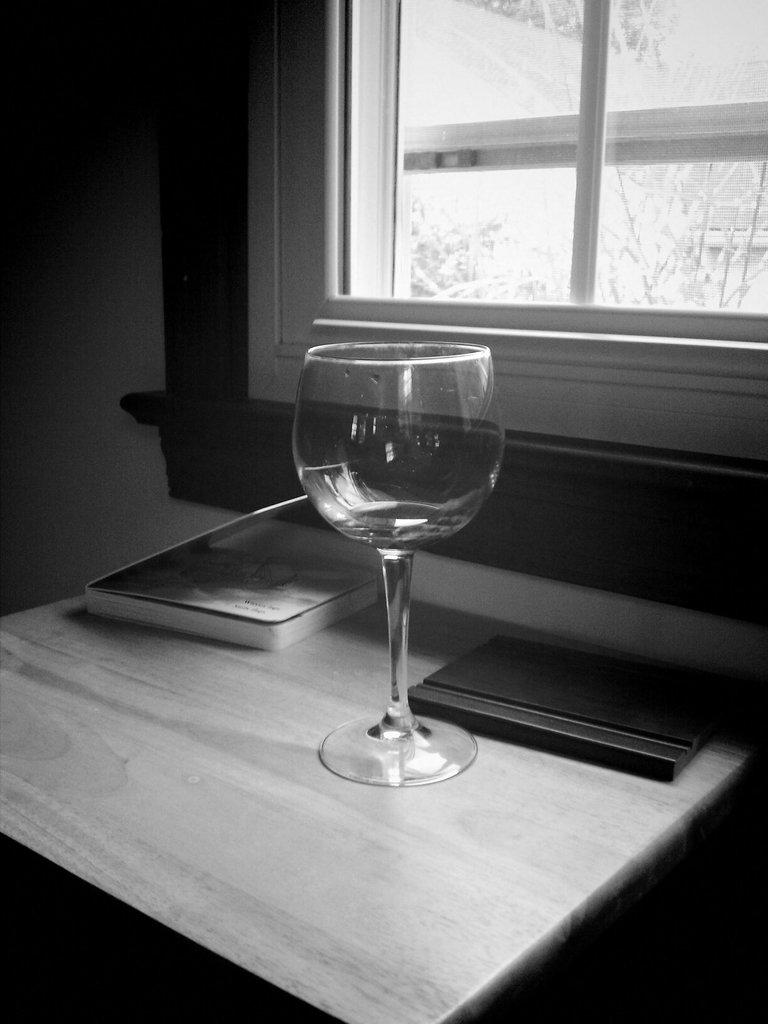What piece of furniture is present in the image? There is a table in the image. What is on the table? The table has an empty glass and two books on it. Is there any source of natural light in the image? Yes, there is a window in the image. What type of horn can be seen on the table in the image? There is no horn present on the table in the image. Is there a volcano visible through the window in the image? There is no volcano visible through the window in the image. 